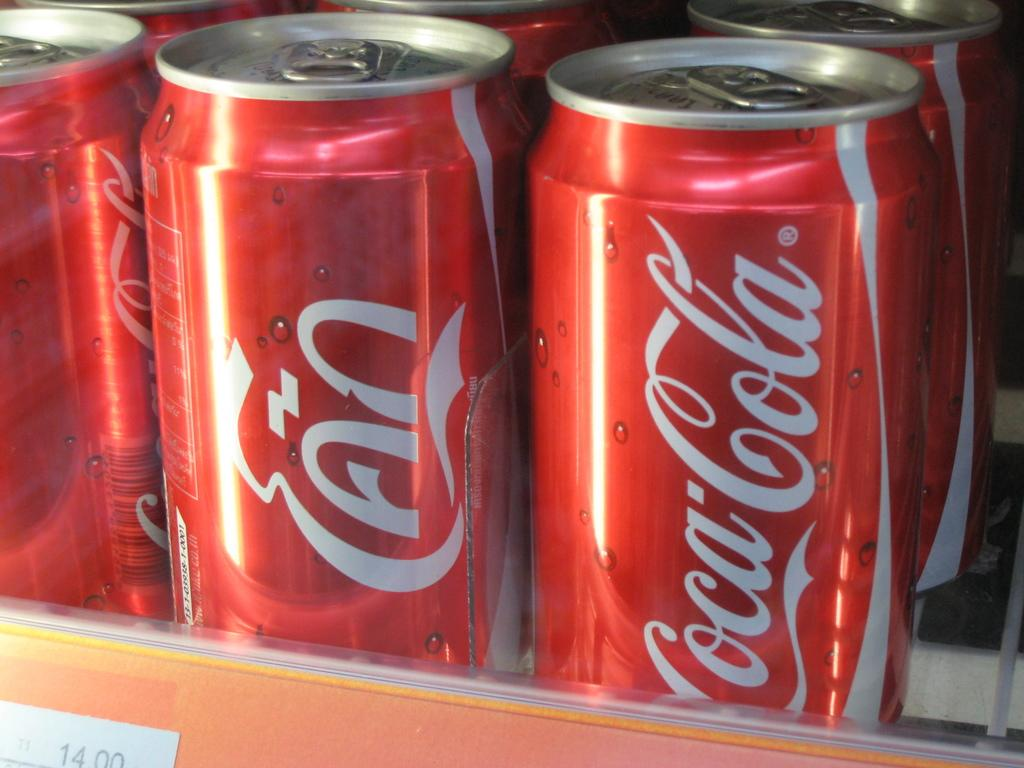<image>
Offer a succinct explanation of the picture presented. a Coca Cola can that is red and white 